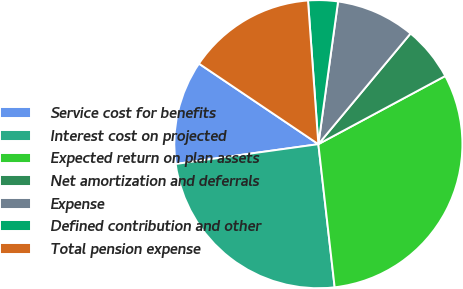<chart> <loc_0><loc_0><loc_500><loc_500><pie_chart><fcel>Service cost for benefits<fcel>Interest cost on projected<fcel>Expected return on plan assets<fcel>Net amortization and deferrals<fcel>Expense<fcel>Defined contribution and other<fcel>Total pension expense<nl><fcel>11.64%<fcel>24.61%<fcel>31.04%<fcel>6.1%<fcel>8.87%<fcel>3.33%<fcel>14.41%<nl></chart> 